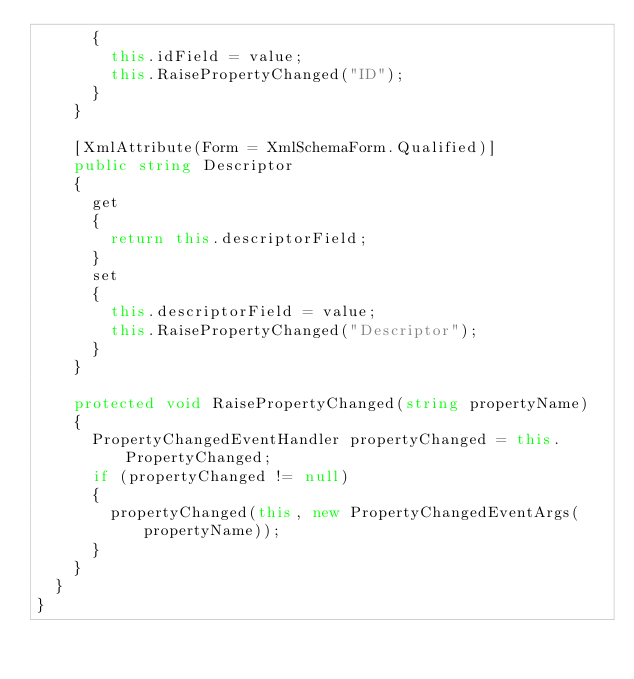Convert code to text. <code><loc_0><loc_0><loc_500><loc_500><_C#_>			{
				this.idField = value;
				this.RaisePropertyChanged("ID");
			}
		}

		[XmlAttribute(Form = XmlSchemaForm.Qualified)]
		public string Descriptor
		{
			get
			{
				return this.descriptorField;
			}
			set
			{
				this.descriptorField = value;
				this.RaisePropertyChanged("Descriptor");
			}
		}

		protected void RaisePropertyChanged(string propertyName)
		{
			PropertyChangedEventHandler propertyChanged = this.PropertyChanged;
			if (propertyChanged != null)
			{
				propertyChanged(this, new PropertyChangedEventArgs(propertyName));
			}
		}
	}
}
</code> 